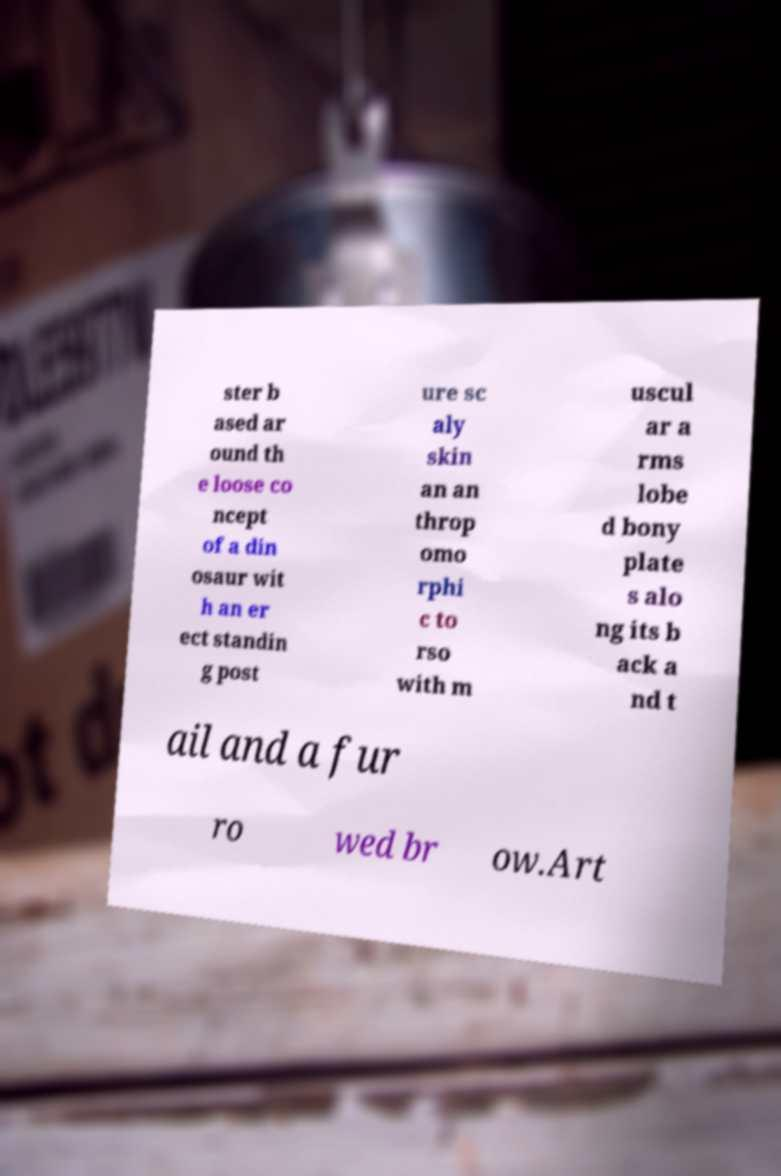Could you extract and type out the text from this image? ster b ased ar ound th e loose co ncept of a din osaur wit h an er ect standin g post ure sc aly skin an an throp omo rphi c to rso with m uscul ar a rms lobe d bony plate s alo ng its b ack a nd t ail and a fur ro wed br ow.Art 